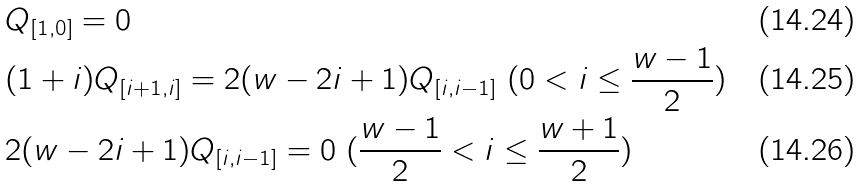Convert formula to latex. <formula><loc_0><loc_0><loc_500><loc_500>& Q _ { [ 1 , 0 ] } = 0 \\ & ( 1 + i ) Q _ { [ i + 1 , i ] } = 2 ( w - 2 i + 1 ) Q _ { [ i , i - 1 ] } \ ( 0 < i \leq \frac { w - 1 } { 2 } ) \\ & 2 ( w - 2 i + 1 ) Q _ { [ i , i - 1 ] } = 0 \ ( \frac { w - 1 } { 2 } < i \leq \frac { w + 1 } { 2 } )</formula> 